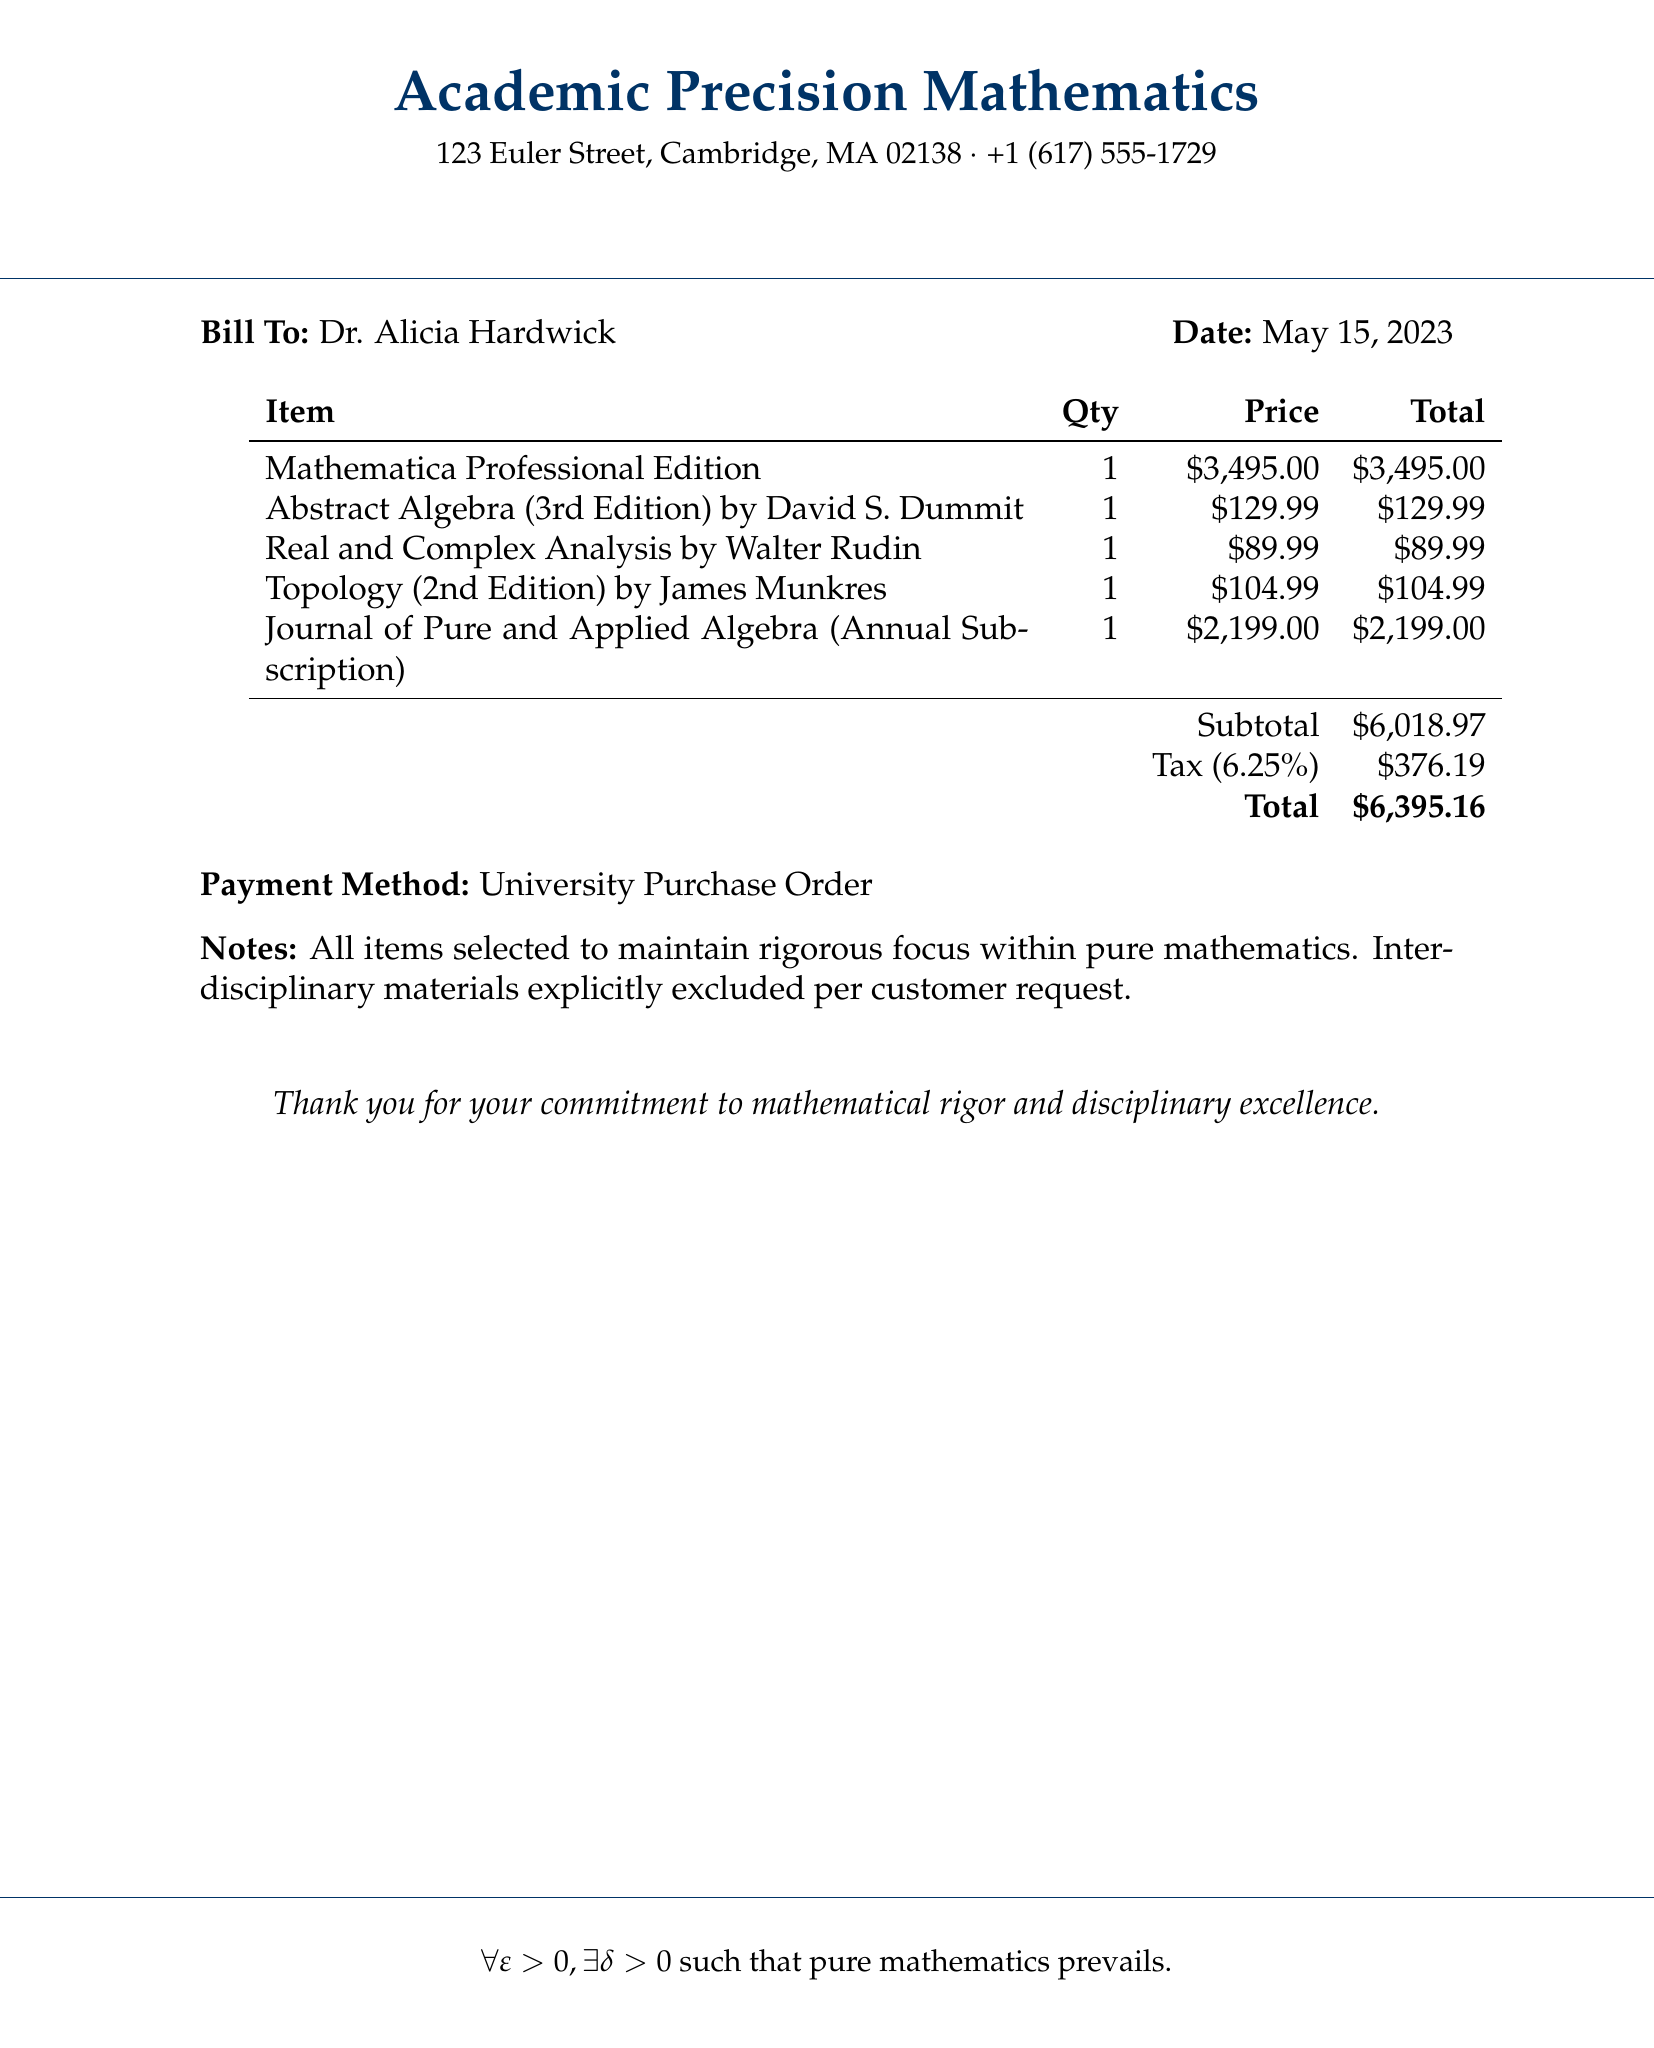What is the total cost listed in the bill? The total cost is found at the end of the bill in the total section, which is $6395.16.
Answer: $6395.16 Who is the bill addressed to? The bill's recipient is mentioned under "Bill To," which indicates Dr. Alicia Hardwick.
Answer: Dr. Alicia Hardwick What is the date of the bill? The date appears prominently in the bill, specifically noting May 15, 2023.
Answer: May 15, 2023 What is the quantity of Mathematica Professional Edition purchased? The quantity is listed next to the item name, showing a count of 1 for Mathematica Professional Edition.
Answer: 1 What is the price of the Abstract Algebra textbook? The price for Abstract Algebra (3rd Edition) is explicitly stated in the document as $129.99.
Answer: $129.99 What type of payment method is indicated in the bill? The payment method is highlighted towards the end, stating University Purchase Order.
Answer: University Purchase Order What is the subtotal before tax on the bill? The subtotal is calculated prior to tax inclusion, shown as $6018.97.
Answer: $6018.97 How much is the tax applied to the subtotal? The tax is calculated as 6.25% of the subtotal, which totals $376.19.
Answer: $376.19 How many items are listed on the bill? The bill includes five distinct items listed under the "Item" column.
Answer: 5 